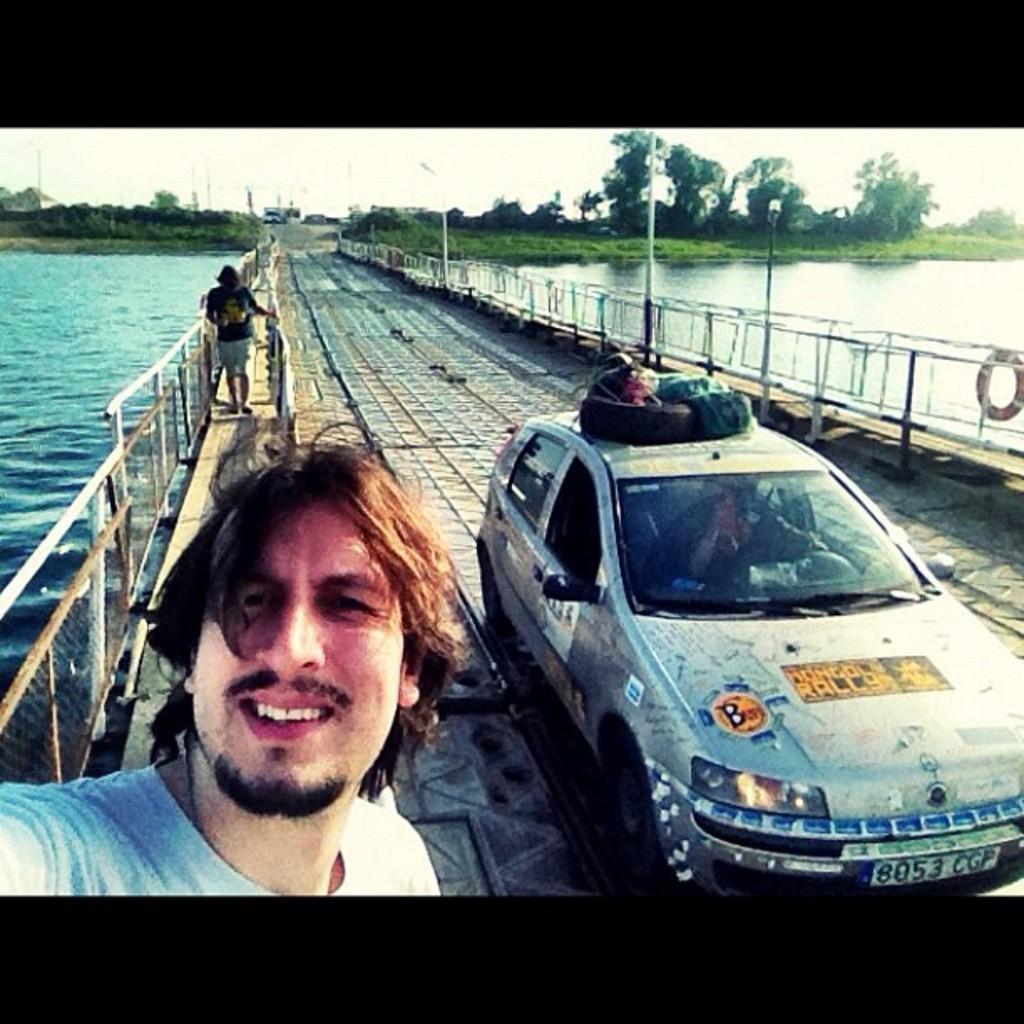Please provide a concise description of this image. In this image we can see a car parked on the bridge. To the left side of the image we can see two persons standing on it and a metal barricade. In the background, we can see a group of poles, water, trees and the sky. 